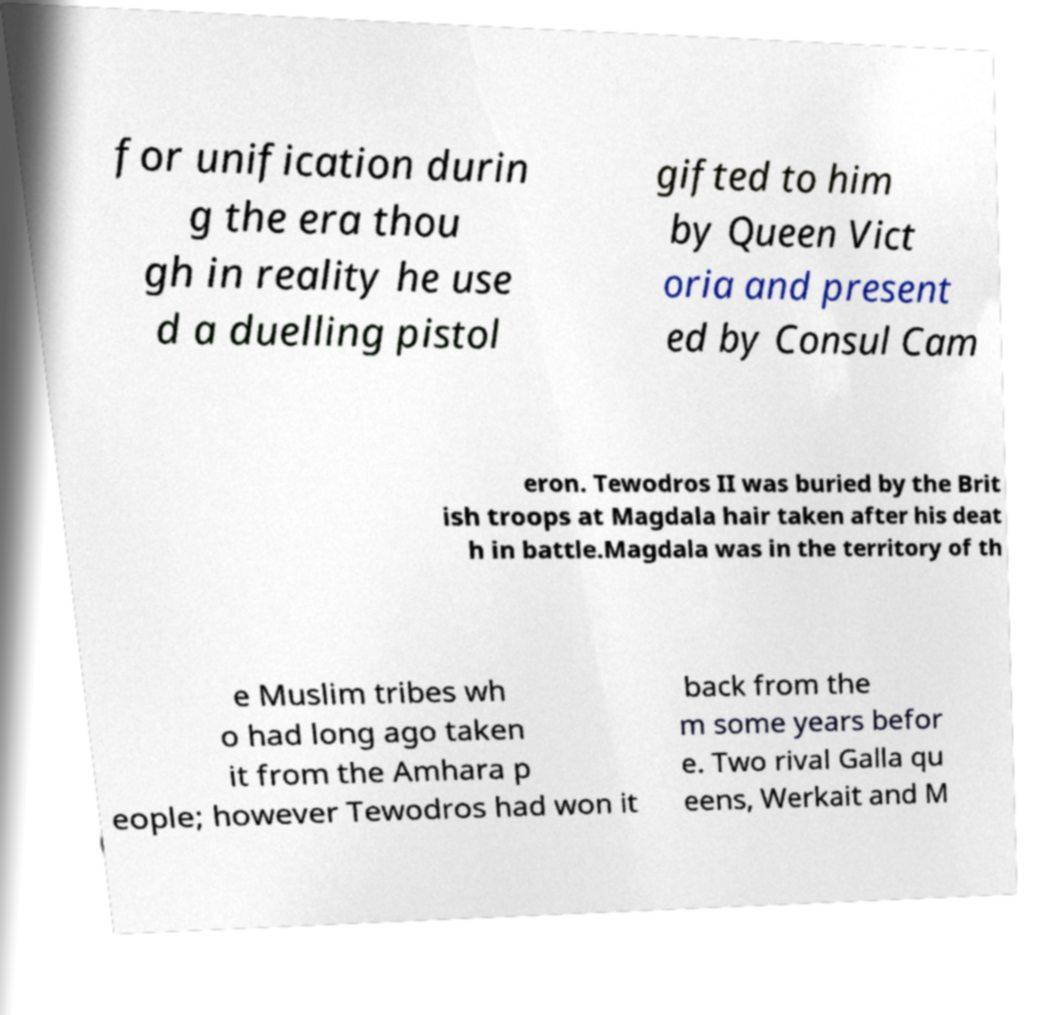I need the written content from this picture converted into text. Can you do that? for unification durin g the era thou gh in reality he use d a duelling pistol gifted to him by Queen Vict oria and present ed by Consul Cam eron. Tewodros II was buried by the Brit ish troops at Magdala hair taken after his deat h in battle.Magdala was in the territory of th e Muslim tribes wh o had long ago taken it from the Amhara p eople; however Tewodros had won it back from the m some years befor e. Two rival Galla qu eens, Werkait and M 